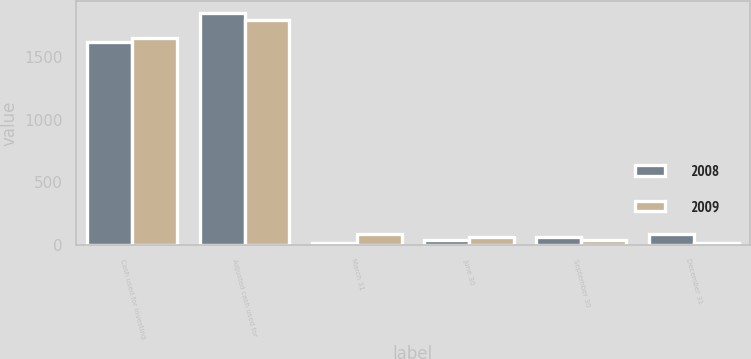Convert chart to OTSL. <chart><loc_0><loc_0><loc_500><loc_500><stacked_bar_chart><ecel><fcel>Cash used for investing<fcel>Adjusted cash used for<fcel>March 31<fcel>June 30<fcel>September 30<fcel>December 31<nl><fcel>2008<fcel>1624.7<fcel>1854.1<fcel>12.5<fcel>37.5<fcel>62.5<fcel>87.5<nl><fcel>2009<fcel>1655.3<fcel>1800.2<fcel>87.5<fcel>62.5<fcel>37.5<fcel>12.5<nl></chart> 